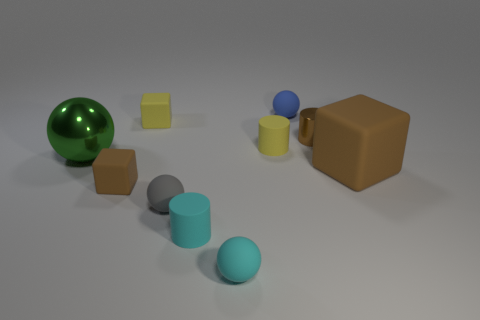What shape is the metal object that is the same color as the large rubber block?
Your answer should be compact. Cylinder. How many other objects are the same size as the blue rubber ball?
Your answer should be compact. 7. Is the shape of the tiny yellow thing that is behind the yellow rubber cylinder the same as  the small brown metallic object?
Provide a short and direct response. No. Are there more tiny blue objects to the left of the big sphere than big brown objects?
Your response must be concise. No. There is a sphere that is both on the right side of the small brown rubber block and to the left of the cyan ball; what material is it made of?
Give a very brief answer. Rubber. Is there any other thing that has the same shape as the big green metal object?
Provide a succinct answer. Yes. How many blocks are in front of the small brown metal thing and behind the green thing?
Ensure brevity in your answer.  0. What is the cyan ball made of?
Make the answer very short. Rubber. Are there an equal number of large brown cubes that are left of the green metallic thing and cyan rubber spheres?
Provide a succinct answer. No. How many small things are the same shape as the large brown rubber object?
Your answer should be compact. 2. 